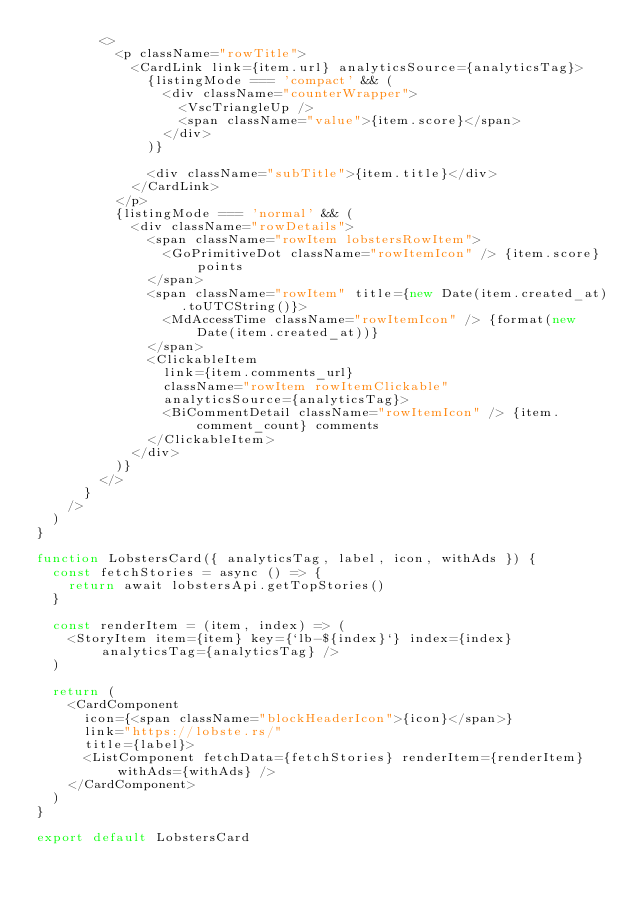Convert code to text. <code><loc_0><loc_0><loc_500><loc_500><_JavaScript_>        <>
          <p className="rowTitle">
            <CardLink link={item.url} analyticsSource={analyticsTag}>
              {listingMode === 'compact' && (
                <div className="counterWrapper">
                  <VscTriangleUp />
                  <span className="value">{item.score}</span>
                </div>
              )}

              <div className="subTitle">{item.title}</div>
            </CardLink>
          </p>
          {listingMode === 'normal' && (
            <div className="rowDetails">
              <span className="rowItem lobstersRowItem">
                <GoPrimitiveDot className="rowItemIcon" /> {item.score} points
              </span>
              <span className="rowItem" title={new Date(item.created_at).toUTCString()}>
                <MdAccessTime className="rowItemIcon" /> {format(new Date(item.created_at))}
              </span>
              <ClickableItem
                link={item.comments_url}
                className="rowItem rowItemClickable"
                analyticsSource={analyticsTag}>
                <BiCommentDetail className="rowItemIcon" /> {item.comment_count} comments
              </ClickableItem>
            </div>
          )}
        </>
      }
    />
  )
}

function LobstersCard({ analyticsTag, label, icon, withAds }) {
  const fetchStories = async () => {
    return await lobstersApi.getTopStories()
  }

  const renderItem = (item, index) => (
    <StoryItem item={item} key={`lb-${index}`} index={index} analyticsTag={analyticsTag} />
  )

  return (
    <CardComponent
      icon={<span className="blockHeaderIcon">{icon}</span>}
      link="https://lobste.rs/"
      title={label}>
      <ListComponent fetchData={fetchStories} renderItem={renderItem} withAds={withAds} />
    </CardComponent>
  )
}

export default LobstersCard
</code> 